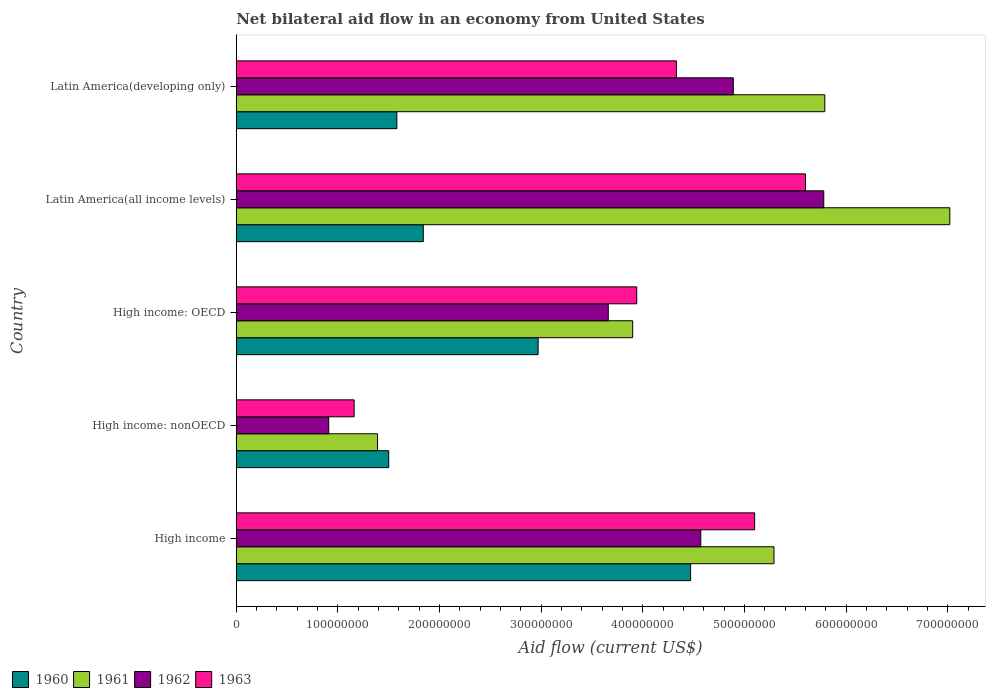Are the number of bars on each tick of the Y-axis equal?
Your answer should be very brief. Yes. How many bars are there on the 1st tick from the bottom?
Your answer should be very brief. 4. What is the label of the 1st group of bars from the top?
Offer a terse response. Latin America(developing only). What is the net bilateral aid flow in 1961 in Latin America(all income levels)?
Offer a very short reply. 7.02e+08. Across all countries, what is the maximum net bilateral aid flow in 1962?
Give a very brief answer. 5.78e+08. Across all countries, what is the minimum net bilateral aid flow in 1963?
Provide a short and direct response. 1.16e+08. In which country was the net bilateral aid flow in 1961 maximum?
Offer a terse response. Latin America(all income levels). In which country was the net bilateral aid flow in 1961 minimum?
Keep it short and to the point. High income: nonOECD. What is the total net bilateral aid flow in 1961 in the graph?
Your answer should be compact. 2.34e+09. What is the difference between the net bilateral aid flow in 1961 in High income: OECD and that in Latin America(all income levels)?
Offer a very short reply. -3.12e+08. What is the difference between the net bilateral aid flow in 1960 in High income and the net bilateral aid flow in 1962 in High income: nonOECD?
Your answer should be very brief. 3.56e+08. What is the average net bilateral aid flow in 1963 per country?
Give a very brief answer. 4.03e+08. What is the difference between the net bilateral aid flow in 1961 and net bilateral aid flow in 1962 in Latin America(all income levels)?
Your response must be concise. 1.24e+08. What is the ratio of the net bilateral aid flow in 1962 in High income: OECD to that in Latin America(developing only)?
Offer a terse response. 0.75. Is the net bilateral aid flow in 1960 in High income less than that in Latin America(developing only)?
Keep it short and to the point. No. Is the difference between the net bilateral aid flow in 1961 in Latin America(all income levels) and Latin America(developing only) greater than the difference between the net bilateral aid flow in 1962 in Latin America(all income levels) and Latin America(developing only)?
Make the answer very short. Yes. What is the difference between the highest and the lowest net bilateral aid flow in 1963?
Keep it short and to the point. 4.44e+08. In how many countries, is the net bilateral aid flow in 1963 greater than the average net bilateral aid flow in 1963 taken over all countries?
Your answer should be compact. 3. What does the 4th bar from the top in High income: OECD represents?
Give a very brief answer. 1960. What does the 3rd bar from the bottom in High income represents?
Provide a succinct answer. 1962. Are all the bars in the graph horizontal?
Offer a terse response. Yes. How many countries are there in the graph?
Ensure brevity in your answer.  5. What is the difference between two consecutive major ticks on the X-axis?
Make the answer very short. 1.00e+08. Are the values on the major ticks of X-axis written in scientific E-notation?
Provide a short and direct response. No. Where does the legend appear in the graph?
Your response must be concise. Bottom left. How many legend labels are there?
Keep it short and to the point. 4. What is the title of the graph?
Give a very brief answer. Net bilateral aid flow in an economy from United States. Does "2000" appear as one of the legend labels in the graph?
Provide a succinct answer. No. What is the Aid flow (current US$) in 1960 in High income?
Keep it short and to the point. 4.47e+08. What is the Aid flow (current US$) in 1961 in High income?
Your answer should be very brief. 5.29e+08. What is the Aid flow (current US$) of 1962 in High income?
Your answer should be compact. 4.57e+08. What is the Aid flow (current US$) of 1963 in High income?
Keep it short and to the point. 5.10e+08. What is the Aid flow (current US$) in 1960 in High income: nonOECD?
Your answer should be very brief. 1.50e+08. What is the Aid flow (current US$) in 1961 in High income: nonOECD?
Give a very brief answer. 1.39e+08. What is the Aid flow (current US$) in 1962 in High income: nonOECD?
Your answer should be very brief. 9.10e+07. What is the Aid flow (current US$) of 1963 in High income: nonOECD?
Make the answer very short. 1.16e+08. What is the Aid flow (current US$) in 1960 in High income: OECD?
Ensure brevity in your answer.  2.97e+08. What is the Aid flow (current US$) in 1961 in High income: OECD?
Your answer should be very brief. 3.90e+08. What is the Aid flow (current US$) of 1962 in High income: OECD?
Provide a succinct answer. 3.66e+08. What is the Aid flow (current US$) of 1963 in High income: OECD?
Your answer should be very brief. 3.94e+08. What is the Aid flow (current US$) of 1960 in Latin America(all income levels)?
Make the answer very short. 1.84e+08. What is the Aid flow (current US$) in 1961 in Latin America(all income levels)?
Offer a terse response. 7.02e+08. What is the Aid flow (current US$) of 1962 in Latin America(all income levels)?
Your response must be concise. 5.78e+08. What is the Aid flow (current US$) in 1963 in Latin America(all income levels)?
Offer a terse response. 5.60e+08. What is the Aid flow (current US$) of 1960 in Latin America(developing only)?
Provide a succinct answer. 1.58e+08. What is the Aid flow (current US$) in 1961 in Latin America(developing only)?
Offer a terse response. 5.79e+08. What is the Aid flow (current US$) in 1962 in Latin America(developing only)?
Give a very brief answer. 4.89e+08. What is the Aid flow (current US$) of 1963 in Latin America(developing only)?
Your response must be concise. 4.33e+08. Across all countries, what is the maximum Aid flow (current US$) of 1960?
Offer a terse response. 4.47e+08. Across all countries, what is the maximum Aid flow (current US$) in 1961?
Your answer should be compact. 7.02e+08. Across all countries, what is the maximum Aid flow (current US$) of 1962?
Your answer should be very brief. 5.78e+08. Across all countries, what is the maximum Aid flow (current US$) in 1963?
Ensure brevity in your answer.  5.60e+08. Across all countries, what is the minimum Aid flow (current US$) in 1960?
Make the answer very short. 1.50e+08. Across all countries, what is the minimum Aid flow (current US$) of 1961?
Provide a succinct answer. 1.39e+08. Across all countries, what is the minimum Aid flow (current US$) of 1962?
Give a very brief answer. 9.10e+07. Across all countries, what is the minimum Aid flow (current US$) of 1963?
Give a very brief answer. 1.16e+08. What is the total Aid flow (current US$) of 1960 in the graph?
Offer a very short reply. 1.24e+09. What is the total Aid flow (current US$) in 1961 in the graph?
Ensure brevity in your answer.  2.34e+09. What is the total Aid flow (current US$) in 1962 in the graph?
Give a very brief answer. 1.98e+09. What is the total Aid flow (current US$) in 1963 in the graph?
Offer a terse response. 2.01e+09. What is the difference between the Aid flow (current US$) of 1960 in High income and that in High income: nonOECD?
Keep it short and to the point. 2.97e+08. What is the difference between the Aid flow (current US$) in 1961 in High income and that in High income: nonOECD?
Your answer should be very brief. 3.90e+08. What is the difference between the Aid flow (current US$) of 1962 in High income and that in High income: nonOECD?
Make the answer very short. 3.66e+08. What is the difference between the Aid flow (current US$) in 1963 in High income and that in High income: nonOECD?
Offer a terse response. 3.94e+08. What is the difference between the Aid flow (current US$) of 1960 in High income and that in High income: OECD?
Your answer should be compact. 1.50e+08. What is the difference between the Aid flow (current US$) in 1961 in High income and that in High income: OECD?
Ensure brevity in your answer.  1.39e+08. What is the difference between the Aid flow (current US$) of 1962 in High income and that in High income: OECD?
Make the answer very short. 9.10e+07. What is the difference between the Aid flow (current US$) of 1963 in High income and that in High income: OECD?
Provide a short and direct response. 1.16e+08. What is the difference between the Aid flow (current US$) of 1960 in High income and that in Latin America(all income levels)?
Provide a succinct answer. 2.63e+08. What is the difference between the Aid flow (current US$) of 1961 in High income and that in Latin America(all income levels)?
Provide a short and direct response. -1.73e+08. What is the difference between the Aid flow (current US$) in 1962 in High income and that in Latin America(all income levels)?
Ensure brevity in your answer.  -1.21e+08. What is the difference between the Aid flow (current US$) in 1963 in High income and that in Latin America(all income levels)?
Offer a very short reply. -5.00e+07. What is the difference between the Aid flow (current US$) in 1960 in High income and that in Latin America(developing only)?
Your answer should be compact. 2.89e+08. What is the difference between the Aid flow (current US$) of 1961 in High income and that in Latin America(developing only)?
Keep it short and to the point. -5.00e+07. What is the difference between the Aid flow (current US$) of 1962 in High income and that in Latin America(developing only)?
Give a very brief answer. -3.20e+07. What is the difference between the Aid flow (current US$) of 1963 in High income and that in Latin America(developing only)?
Your answer should be very brief. 7.70e+07. What is the difference between the Aid flow (current US$) of 1960 in High income: nonOECD and that in High income: OECD?
Your answer should be compact. -1.47e+08. What is the difference between the Aid flow (current US$) of 1961 in High income: nonOECD and that in High income: OECD?
Give a very brief answer. -2.51e+08. What is the difference between the Aid flow (current US$) of 1962 in High income: nonOECD and that in High income: OECD?
Give a very brief answer. -2.75e+08. What is the difference between the Aid flow (current US$) in 1963 in High income: nonOECD and that in High income: OECD?
Keep it short and to the point. -2.78e+08. What is the difference between the Aid flow (current US$) in 1960 in High income: nonOECD and that in Latin America(all income levels)?
Your answer should be very brief. -3.40e+07. What is the difference between the Aid flow (current US$) of 1961 in High income: nonOECD and that in Latin America(all income levels)?
Provide a succinct answer. -5.63e+08. What is the difference between the Aid flow (current US$) in 1962 in High income: nonOECD and that in Latin America(all income levels)?
Provide a succinct answer. -4.87e+08. What is the difference between the Aid flow (current US$) in 1963 in High income: nonOECD and that in Latin America(all income levels)?
Offer a very short reply. -4.44e+08. What is the difference between the Aid flow (current US$) of 1960 in High income: nonOECD and that in Latin America(developing only)?
Make the answer very short. -8.00e+06. What is the difference between the Aid flow (current US$) in 1961 in High income: nonOECD and that in Latin America(developing only)?
Provide a short and direct response. -4.40e+08. What is the difference between the Aid flow (current US$) of 1962 in High income: nonOECD and that in Latin America(developing only)?
Offer a terse response. -3.98e+08. What is the difference between the Aid flow (current US$) of 1963 in High income: nonOECD and that in Latin America(developing only)?
Offer a terse response. -3.17e+08. What is the difference between the Aid flow (current US$) in 1960 in High income: OECD and that in Latin America(all income levels)?
Give a very brief answer. 1.13e+08. What is the difference between the Aid flow (current US$) in 1961 in High income: OECD and that in Latin America(all income levels)?
Your answer should be very brief. -3.12e+08. What is the difference between the Aid flow (current US$) in 1962 in High income: OECD and that in Latin America(all income levels)?
Provide a succinct answer. -2.12e+08. What is the difference between the Aid flow (current US$) of 1963 in High income: OECD and that in Latin America(all income levels)?
Offer a terse response. -1.66e+08. What is the difference between the Aid flow (current US$) in 1960 in High income: OECD and that in Latin America(developing only)?
Provide a succinct answer. 1.39e+08. What is the difference between the Aid flow (current US$) of 1961 in High income: OECD and that in Latin America(developing only)?
Provide a short and direct response. -1.89e+08. What is the difference between the Aid flow (current US$) of 1962 in High income: OECD and that in Latin America(developing only)?
Your answer should be compact. -1.23e+08. What is the difference between the Aid flow (current US$) in 1963 in High income: OECD and that in Latin America(developing only)?
Your response must be concise. -3.90e+07. What is the difference between the Aid flow (current US$) in 1960 in Latin America(all income levels) and that in Latin America(developing only)?
Provide a succinct answer. 2.60e+07. What is the difference between the Aid flow (current US$) in 1961 in Latin America(all income levels) and that in Latin America(developing only)?
Your answer should be compact. 1.23e+08. What is the difference between the Aid flow (current US$) of 1962 in Latin America(all income levels) and that in Latin America(developing only)?
Give a very brief answer. 8.90e+07. What is the difference between the Aid flow (current US$) in 1963 in Latin America(all income levels) and that in Latin America(developing only)?
Give a very brief answer. 1.27e+08. What is the difference between the Aid flow (current US$) in 1960 in High income and the Aid flow (current US$) in 1961 in High income: nonOECD?
Provide a succinct answer. 3.08e+08. What is the difference between the Aid flow (current US$) in 1960 in High income and the Aid flow (current US$) in 1962 in High income: nonOECD?
Provide a succinct answer. 3.56e+08. What is the difference between the Aid flow (current US$) of 1960 in High income and the Aid flow (current US$) of 1963 in High income: nonOECD?
Offer a terse response. 3.31e+08. What is the difference between the Aid flow (current US$) of 1961 in High income and the Aid flow (current US$) of 1962 in High income: nonOECD?
Offer a terse response. 4.38e+08. What is the difference between the Aid flow (current US$) in 1961 in High income and the Aid flow (current US$) in 1963 in High income: nonOECD?
Ensure brevity in your answer.  4.13e+08. What is the difference between the Aid flow (current US$) in 1962 in High income and the Aid flow (current US$) in 1963 in High income: nonOECD?
Offer a terse response. 3.41e+08. What is the difference between the Aid flow (current US$) in 1960 in High income and the Aid flow (current US$) in 1961 in High income: OECD?
Offer a terse response. 5.70e+07. What is the difference between the Aid flow (current US$) of 1960 in High income and the Aid flow (current US$) of 1962 in High income: OECD?
Keep it short and to the point. 8.10e+07. What is the difference between the Aid flow (current US$) in 1960 in High income and the Aid flow (current US$) in 1963 in High income: OECD?
Provide a short and direct response. 5.30e+07. What is the difference between the Aid flow (current US$) in 1961 in High income and the Aid flow (current US$) in 1962 in High income: OECD?
Ensure brevity in your answer.  1.63e+08. What is the difference between the Aid flow (current US$) of 1961 in High income and the Aid flow (current US$) of 1963 in High income: OECD?
Provide a short and direct response. 1.35e+08. What is the difference between the Aid flow (current US$) in 1962 in High income and the Aid flow (current US$) in 1963 in High income: OECD?
Offer a terse response. 6.30e+07. What is the difference between the Aid flow (current US$) of 1960 in High income and the Aid flow (current US$) of 1961 in Latin America(all income levels)?
Your answer should be compact. -2.55e+08. What is the difference between the Aid flow (current US$) of 1960 in High income and the Aid flow (current US$) of 1962 in Latin America(all income levels)?
Provide a succinct answer. -1.31e+08. What is the difference between the Aid flow (current US$) in 1960 in High income and the Aid flow (current US$) in 1963 in Latin America(all income levels)?
Offer a very short reply. -1.13e+08. What is the difference between the Aid flow (current US$) in 1961 in High income and the Aid flow (current US$) in 1962 in Latin America(all income levels)?
Your answer should be very brief. -4.90e+07. What is the difference between the Aid flow (current US$) of 1961 in High income and the Aid flow (current US$) of 1963 in Latin America(all income levels)?
Make the answer very short. -3.10e+07. What is the difference between the Aid flow (current US$) in 1962 in High income and the Aid flow (current US$) in 1963 in Latin America(all income levels)?
Provide a succinct answer. -1.03e+08. What is the difference between the Aid flow (current US$) in 1960 in High income and the Aid flow (current US$) in 1961 in Latin America(developing only)?
Make the answer very short. -1.32e+08. What is the difference between the Aid flow (current US$) in 1960 in High income and the Aid flow (current US$) in 1962 in Latin America(developing only)?
Keep it short and to the point. -4.20e+07. What is the difference between the Aid flow (current US$) of 1960 in High income and the Aid flow (current US$) of 1963 in Latin America(developing only)?
Your answer should be very brief. 1.40e+07. What is the difference between the Aid flow (current US$) of 1961 in High income and the Aid flow (current US$) of 1962 in Latin America(developing only)?
Provide a short and direct response. 4.00e+07. What is the difference between the Aid flow (current US$) of 1961 in High income and the Aid flow (current US$) of 1963 in Latin America(developing only)?
Offer a terse response. 9.60e+07. What is the difference between the Aid flow (current US$) in 1962 in High income and the Aid flow (current US$) in 1963 in Latin America(developing only)?
Your answer should be very brief. 2.40e+07. What is the difference between the Aid flow (current US$) in 1960 in High income: nonOECD and the Aid flow (current US$) in 1961 in High income: OECD?
Keep it short and to the point. -2.40e+08. What is the difference between the Aid flow (current US$) of 1960 in High income: nonOECD and the Aid flow (current US$) of 1962 in High income: OECD?
Keep it short and to the point. -2.16e+08. What is the difference between the Aid flow (current US$) of 1960 in High income: nonOECD and the Aid flow (current US$) of 1963 in High income: OECD?
Keep it short and to the point. -2.44e+08. What is the difference between the Aid flow (current US$) in 1961 in High income: nonOECD and the Aid flow (current US$) in 1962 in High income: OECD?
Provide a short and direct response. -2.27e+08. What is the difference between the Aid flow (current US$) in 1961 in High income: nonOECD and the Aid flow (current US$) in 1963 in High income: OECD?
Your answer should be very brief. -2.55e+08. What is the difference between the Aid flow (current US$) of 1962 in High income: nonOECD and the Aid flow (current US$) of 1963 in High income: OECD?
Keep it short and to the point. -3.03e+08. What is the difference between the Aid flow (current US$) in 1960 in High income: nonOECD and the Aid flow (current US$) in 1961 in Latin America(all income levels)?
Your answer should be very brief. -5.52e+08. What is the difference between the Aid flow (current US$) in 1960 in High income: nonOECD and the Aid flow (current US$) in 1962 in Latin America(all income levels)?
Offer a terse response. -4.28e+08. What is the difference between the Aid flow (current US$) of 1960 in High income: nonOECD and the Aid flow (current US$) of 1963 in Latin America(all income levels)?
Offer a very short reply. -4.10e+08. What is the difference between the Aid flow (current US$) in 1961 in High income: nonOECD and the Aid flow (current US$) in 1962 in Latin America(all income levels)?
Your answer should be very brief. -4.39e+08. What is the difference between the Aid flow (current US$) in 1961 in High income: nonOECD and the Aid flow (current US$) in 1963 in Latin America(all income levels)?
Keep it short and to the point. -4.21e+08. What is the difference between the Aid flow (current US$) of 1962 in High income: nonOECD and the Aid flow (current US$) of 1963 in Latin America(all income levels)?
Provide a succinct answer. -4.69e+08. What is the difference between the Aid flow (current US$) in 1960 in High income: nonOECD and the Aid flow (current US$) in 1961 in Latin America(developing only)?
Your answer should be very brief. -4.29e+08. What is the difference between the Aid flow (current US$) in 1960 in High income: nonOECD and the Aid flow (current US$) in 1962 in Latin America(developing only)?
Provide a succinct answer. -3.39e+08. What is the difference between the Aid flow (current US$) in 1960 in High income: nonOECD and the Aid flow (current US$) in 1963 in Latin America(developing only)?
Offer a very short reply. -2.83e+08. What is the difference between the Aid flow (current US$) in 1961 in High income: nonOECD and the Aid flow (current US$) in 1962 in Latin America(developing only)?
Your answer should be compact. -3.50e+08. What is the difference between the Aid flow (current US$) of 1961 in High income: nonOECD and the Aid flow (current US$) of 1963 in Latin America(developing only)?
Ensure brevity in your answer.  -2.94e+08. What is the difference between the Aid flow (current US$) in 1962 in High income: nonOECD and the Aid flow (current US$) in 1963 in Latin America(developing only)?
Your answer should be compact. -3.42e+08. What is the difference between the Aid flow (current US$) of 1960 in High income: OECD and the Aid flow (current US$) of 1961 in Latin America(all income levels)?
Offer a very short reply. -4.05e+08. What is the difference between the Aid flow (current US$) in 1960 in High income: OECD and the Aid flow (current US$) in 1962 in Latin America(all income levels)?
Give a very brief answer. -2.81e+08. What is the difference between the Aid flow (current US$) of 1960 in High income: OECD and the Aid flow (current US$) of 1963 in Latin America(all income levels)?
Provide a succinct answer. -2.63e+08. What is the difference between the Aid flow (current US$) of 1961 in High income: OECD and the Aid flow (current US$) of 1962 in Latin America(all income levels)?
Provide a succinct answer. -1.88e+08. What is the difference between the Aid flow (current US$) of 1961 in High income: OECD and the Aid flow (current US$) of 1963 in Latin America(all income levels)?
Provide a short and direct response. -1.70e+08. What is the difference between the Aid flow (current US$) in 1962 in High income: OECD and the Aid flow (current US$) in 1963 in Latin America(all income levels)?
Offer a terse response. -1.94e+08. What is the difference between the Aid flow (current US$) of 1960 in High income: OECD and the Aid flow (current US$) of 1961 in Latin America(developing only)?
Make the answer very short. -2.82e+08. What is the difference between the Aid flow (current US$) in 1960 in High income: OECD and the Aid flow (current US$) in 1962 in Latin America(developing only)?
Make the answer very short. -1.92e+08. What is the difference between the Aid flow (current US$) in 1960 in High income: OECD and the Aid flow (current US$) in 1963 in Latin America(developing only)?
Keep it short and to the point. -1.36e+08. What is the difference between the Aid flow (current US$) of 1961 in High income: OECD and the Aid flow (current US$) of 1962 in Latin America(developing only)?
Keep it short and to the point. -9.90e+07. What is the difference between the Aid flow (current US$) in 1961 in High income: OECD and the Aid flow (current US$) in 1963 in Latin America(developing only)?
Make the answer very short. -4.30e+07. What is the difference between the Aid flow (current US$) of 1962 in High income: OECD and the Aid flow (current US$) of 1963 in Latin America(developing only)?
Give a very brief answer. -6.70e+07. What is the difference between the Aid flow (current US$) of 1960 in Latin America(all income levels) and the Aid flow (current US$) of 1961 in Latin America(developing only)?
Provide a short and direct response. -3.95e+08. What is the difference between the Aid flow (current US$) in 1960 in Latin America(all income levels) and the Aid flow (current US$) in 1962 in Latin America(developing only)?
Make the answer very short. -3.05e+08. What is the difference between the Aid flow (current US$) of 1960 in Latin America(all income levels) and the Aid flow (current US$) of 1963 in Latin America(developing only)?
Your response must be concise. -2.49e+08. What is the difference between the Aid flow (current US$) of 1961 in Latin America(all income levels) and the Aid flow (current US$) of 1962 in Latin America(developing only)?
Your answer should be very brief. 2.13e+08. What is the difference between the Aid flow (current US$) in 1961 in Latin America(all income levels) and the Aid flow (current US$) in 1963 in Latin America(developing only)?
Give a very brief answer. 2.69e+08. What is the difference between the Aid flow (current US$) in 1962 in Latin America(all income levels) and the Aid flow (current US$) in 1963 in Latin America(developing only)?
Your response must be concise. 1.45e+08. What is the average Aid flow (current US$) in 1960 per country?
Give a very brief answer. 2.47e+08. What is the average Aid flow (current US$) in 1961 per country?
Your answer should be compact. 4.68e+08. What is the average Aid flow (current US$) in 1962 per country?
Your response must be concise. 3.96e+08. What is the average Aid flow (current US$) in 1963 per country?
Your response must be concise. 4.03e+08. What is the difference between the Aid flow (current US$) of 1960 and Aid flow (current US$) of 1961 in High income?
Provide a short and direct response. -8.20e+07. What is the difference between the Aid flow (current US$) of 1960 and Aid flow (current US$) of 1962 in High income?
Your answer should be very brief. -1.00e+07. What is the difference between the Aid flow (current US$) of 1960 and Aid flow (current US$) of 1963 in High income?
Give a very brief answer. -6.30e+07. What is the difference between the Aid flow (current US$) in 1961 and Aid flow (current US$) in 1962 in High income?
Your answer should be very brief. 7.20e+07. What is the difference between the Aid flow (current US$) of 1961 and Aid flow (current US$) of 1963 in High income?
Your answer should be compact. 1.90e+07. What is the difference between the Aid flow (current US$) in 1962 and Aid flow (current US$) in 1963 in High income?
Make the answer very short. -5.30e+07. What is the difference between the Aid flow (current US$) in 1960 and Aid flow (current US$) in 1961 in High income: nonOECD?
Your response must be concise. 1.10e+07. What is the difference between the Aid flow (current US$) of 1960 and Aid flow (current US$) of 1962 in High income: nonOECD?
Your response must be concise. 5.90e+07. What is the difference between the Aid flow (current US$) in 1960 and Aid flow (current US$) in 1963 in High income: nonOECD?
Ensure brevity in your answer.  3.40e+07. What is the difference between the Aid flow (current US$) in 1961 and Aid flow (current US$) in 1962 in High income: nonOECD?
Your answer should be compact. 4.80e+07. What is the difference between the Aid flow (current US$) in 1961 and Aid flow (current US$) in 1963 in High income: nonOECD?
Make the answer very short. 2.30e+07. What is the difference between the Aid flow (current US$) of 1962 and Aid flow (current US$) of 1963 in High income: nonOECD?
Make the answer very short. -2.50e+07. What is the difference between the Aid flow (current US$) in 1960 and Aid flow (current US$) in 1961 in High income: OECD?
Provide a succinct answer. -9.30e+07. What is the difference between the Aid flow (current US$) in 1960 and Aid flow (current US$) in 1962 in High income: OECD?
Give a very brief answer. -6.90e+07. What is the difference between the Aid flow (current US$) in 1960 and Aid flow (current US$) in 1963 in High income: OECD?
Your answer should be very brief. -9.70e+07. What is the difference between the Aid flow (current US$) of 1961 and Aid flow (current US$) of 1962 in High income: OECD?
Keep it short and to the point. 2.40e+07. What is the difference between the Aid flow (current US$) of 1962 and Aid flow (current US$) of 1963 in High income: OECD?
Offer a very short reply. -2.80e+07. What is the difference between the Aid flow (current US$) in 1960 and Aid flow (current US$) in 1961 in Latin America(all income levels)?
Provide a short and direct response. -5.18e+08. What is the difference between the Aid flow (current US$) of 1960 and Aid flow (current US$) of 1962 in Latin America(all income levels)?
Provide a short and direct response. -3.94e+08. What is the difference between the Aid flow (current US$) of 1960 and Aid flow (current US$) of 1963 in Latin America(all income levels)?
Offer a very short reply. -3.76e+08. What is the difference between the Aid flow (current US$) of 1961 and Aid flow (current US$) of 1962 in Latin America(all income levels)?
Offer a terse response. 1.24e+08. What is the difference between the Aid flow (current US$) of 1961 and Aid flow (current US$) of 1963 in Latin America(all income levels)?
Offer a very short reply. 1.42e+08. What is the difference between the Aid flow (current US$) of 1962 and Aid flow (current US$) of 1963 in Latin America(all income levels)?
Your response must be concise. 1.80e+07. What is the difference between the Aid flow (current US$) of 1960 and Aid flow (current US$) of 1961 in Latin America(developing only)?
Make the answer very short. -4.21e+08. What is the difference between the Aid flow (current US$) of 1960 and Aid flow (current US$) of 1962 in Latin America(developing only)?
Give a very brief answer. -3.31e+08. What is the difference between the Aid flow (current US$) of 1960 and Aid flow (current US$) of 1963 in Latin America(developing only)?
Ensure brevity in your answer.  -2.75e+08. What is the difference between the Aid flow (current US$) of 1961 and Aid flow (current US$) of 1962 in Latin America(developing only)?
Offer a terse response. 9.00e+07. What is the difference between the Aid flow (current US$) of 1961 and Aid flow (current US$) of 1963 in Latin America(developing only)?
Provide a succinct answer. 1.46e+08. What is the difference between the Aid flow (current US$) of 1962 and Aid flow (current US$) of 1963 in Latin America(developing only)?
Offer a very short reply. 5.60e+07. What is the ratio of the Aid flow (current US$) in 1960 in High income to that in High income: nonOECD?
Make the answer very short. 2.98. What is the ratio of the Aid flow (current US$) in 1961 in High income to that in High income: nonOECD?
Offer a terse response. 3.81. What is the ratio of the Aid flow (current US$) in 1962 in High income to that in High income: nonOECD?
Your answer should be compact. 5.02. What is the ratio of the Aid flow (current US$) in 1963 in High income to that in High income: nonOECD?
Give a very brief answer. 4.4. What is the ratio of the Aid flow (current US$) in 1960 in High income to that in High income: OECD?
Your answer should be compact. 1.51. What is the ratio of the Aid flow (current US$) of 1961 in High income to that in High income: OECD?
Make the answer very short. 1.36. What is the ratio of the Aid flow (current US$) of 1962 in High income to that in High income: OECD?
Give a very brief answer. 1.25. What is the ratio of the Aid flow (current US$) in 1963 in High income to that in High income: OECD?
Your response must be concise. 1.29. What is the ratio of the Aid flow (current US$) in 1960 in High income to that in Latin America(all income levels)?
Provide a succinct answer. 2.43. What is the ratio of the Aid flow (current US$) in 1961 in High income to that in Latin America(all income levels)?
Keep it short and to the point. 0.75. What is the ratio of the Aid flow (current US$) in 1962 in High income to that in Latin America(all income levels)?
Your answer should be very brief. 0.79. What is the ratio of the Aid flow (current US$) of 1963 in High income to that in Latin America(all income levels)?
Keep it short and to the point. 0.91. What is the ratio of the Aid flow (current US$) in 1960 in High income to that in Latin America(developing only)?
Offer a terse response. 2.83. What is the ratio of the Aid flow (current US$) of 1961 in High income to that in Latin America(developing only)?
Provide a short and direct response. 0.91. What is the ratio of the Aid flow (current US$) in 1962 in High income to that in Latin America(developing only)?
Keep it short and to the point. 0.93. What is the ratio of the Aid flow (current US$) of 1963 in High income to that in Latin America(developing only)?
Offer a terse response. 1.18. What is the ratio of the Aid flow (current US$) of 1960 in High income: nonOECD to that in High income: OECD?
Your answer should be compact. 0.51. What is the ratio of the Aid flow (current US$) in 1961 in High income: nonOECD to that in High income: OECD?
Offer a terse response. 0.36. What is the ratio of the Aid flow (current US$) in 1962 in High income: nonOECD to that in High income: OECD?
Provide a short and direct response. 0.25. What is the ratio of the Aid flow (current US$) of 1963 in High income: nonOECD to that in High income: OECD?
Make the answer very short. 0.29. What is the ratio of the Aid flow (current US$) in 1960 in High income: nonOECD to that in Latin America(all income levels)?
Your answer should be very brief. 0.82. What is the ratio of the Aid flow (current US$) of 1961 in High income: nonOECD to that in Latin America(all income levels)?
Offer a terse response. 0.2. What is the ratio of the Aid flow (current US$) in 1962 in High income: nonOECD to that in Latin America(all income levels)?
Offer a terse response. 0.16. What is the ratio of the Aid flow (current US$) in 1963 in High income: nonOECD to that in Latin America(all income levels)?
Offer a terse response. 0.21. What is the ratio of the Aid flow (current US$) of 1960 in High income: nonOECD to that in Latin America(developing only)?
Your answer should be compact. 0.95. What is the ratio of the Aid flow (current US$) in 1961 in High income: nonOECD to that in Latin America(developing only)?
Your answer should be compact. 0.24. What is the ratio of the Aid flow (current US$) in 1962 in High income: nonOECD to that in Latin America(developing only)?
Give a very brief answer. 0.19. What is the ratio of the Aid flow (current US$) of 1963 in High income: nonOECD to that in Latin America(developing only)?
Make the answer very short. 0.27. What is the ratio of the Aid flow (current US$) in 1960 in High income: OECD to that in Latin America(all income levels)?
Keep it short and to the point. 1.61. What is the ratio of the Aid flow (current US$) in 1961 in High income: OECD to that in Latin America(all income levels)?
Offer a terse response. 0.56. What is the ratio of the Aid flow (current US$) in 1962 in High income: OECD to that in Latin America(all income levels)?
Provide a succinct answer. 0.63. What is the ratio of the Aid flow (current US$) in 1963 in High income: OECD to that in Latin America(all income levels)?
Ensure brevity in your answer.  0.7. What is the ratio of the Aid flow (current US$) in 1960 in High income: OECD to that in Latin America(developing only)?
Make the answer very short. 1.88. What is the ratio of the Aid flow (current US$) of 1961 in High income: OECD to that in Latin America(developing only)?
Your answer should be very brief. 0.67. What is the ratio of the Aid flow (current US$) in 1962 in High income: OECD to that in Latin America(developing only)?
Ensure brevity in your answer.  0.75. What is the ratio of the Aid flow (current US$) of 1963 in High income: OECD to that in Latin America(developing only)?
Your response must be concise. 0.91. What is the ratio of the Aid flow (current US$) in 1960 in Latin America(all income levels) to that in Latin America(developing only)?
Offer a terse response. 1.16. What is the ratio of the Aid flow (current US$) in 1961 in Latin America(all income levels) to that in Latin America(developing only)?
Ensure brevity in your answer.  1.21. What is the ratio of the Aid flow (current US$) in 1962 in Latin America(all income levels) to that in Latin America(developing only)?
Give a very brief answer. 1.18. What is the ratio of the Aid flow (current US$) of 1963 in Latin America(all income levels) to that in Latin America(developing only)?
Keep it short and to the point. 1.29. What is the difference between the highest and the second highest Aid flow (current US$) of 1960?
Give a very brief answer. 1.50e+08. What is the difference between the highest and the second highest Aid flow (current US$) in 1961?
Provide a succinct answer. 1.23e+08. What is the difference between the highest and the second highest Aid flow (current US$) of 1962?
Offer a terse response. 8.90e+07. What is the difference between the highest and the second highest Aid flow (current US$) of 1963?
Your answer should be very brief. 5.00e+07. What is the difference between the highest and the lowest Aid flow (current US$) in 1960?
Ensure brevity in your answer.  2.97e+08. What is the difference between the highest and the lowest Aid flow (current US$) of 1961?
Your response must be concise. 5.63e+08. What is the difference between the highest and the lowest Aid flow (current US$) of 1962?
Your answer should be very brief. 4.87e+08. What is the difference between the highest and the lowest Aid flow (current US$) in 1963?
Offer a very short reply. 4.44e+08. 